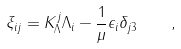<formula> <loc_0><loc_0><loc_500><loc_500>\xi _ { i j } = K _ { \Lambda } ^ { j } \Lambda _ { i } - \frac { 1 } { \mu } \epsilon _ { i } \delta _ { j 3 } \quad ,</formula> 